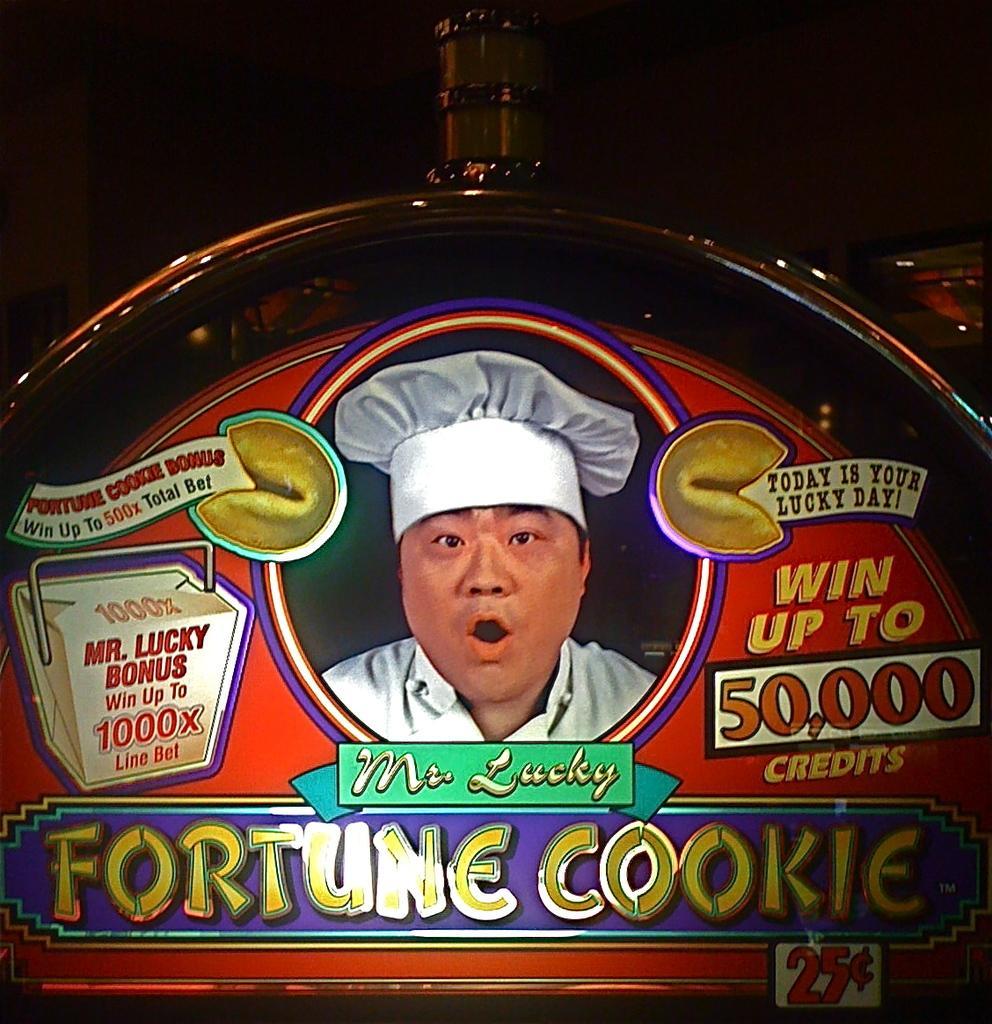Please provide a concise description of this image. This is a poster,on this poster we can see a person,some text and in the background we can see it is dark. 